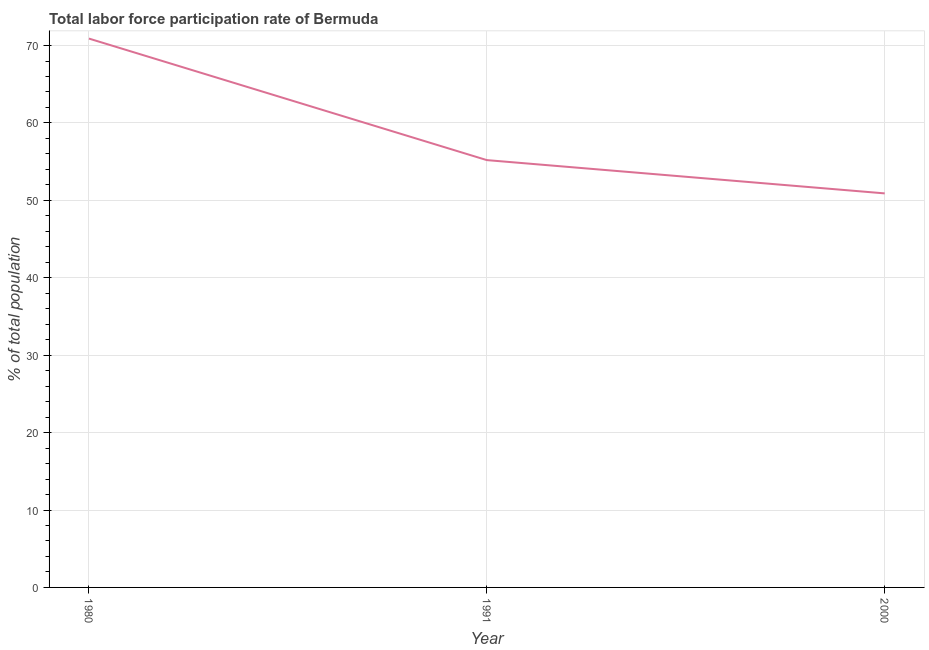What is the total labor force participation rate in 1991?
Offer a very short reply. 55.2. Across all years, what is the maximum total labor force participation rate?
Provide a succinct answer. 70.9. Across all years, what is the minimum total labor force participation rate?
Offer a terse response. 50.9. In which year was the total labor force participation rate maximum?
Your answer should be compact. 1980. In which year was the total labor force participation rate minimum?
Provide a short and direct response. 2000. What is the sum of the total labor force participation rate?
Ensure brevity in your answer.  177. What is the difference between the total labor force participation rate in 1980 and 2000?
Offer a very short reply. 20. What is the average total labor force participation rate per year?
Offer a terse response. 59. What is the median total labor force participation rate?
Give a very brief answer. 55.2. What is the ratio of the total labor force participation rate in 1991 to that in 2000?
Your answer should be very brief. 1.08. Is the difference between the total labor force participation rate in 1991 and 2000 greater than the difference between any two years?
Offer a very short reply. No. What is the difference between the highest and the second highest total labor force participation rate?
Give a very brief answer. 15.7. What is the difference between the highest and the lowest total labor force participation rate?
Give a very brief answer. 20. In how many years, is the total labor force participation rate greater than the average total labor force participation rate taken over all years?
Make the answer very short. 1. Does the total labor force participation rate monotonically increase over the years?
Offer a terse response. No. How many lines are there?
Your answer should be compact. 1. What is the difference between two consecutive major ticks on the Y-axis?
Provide a succinct answer. 10. Does the graph contain any zero values?
Give a very brief answer. No. Does the graph contain grids?
Keep it short and to the point. Yes. What is the title of the graph?
Your response must be concise. Total labor force participation rate of Bermuda. What is the label or title of the Y-axis?
Your answer should be very brief. % of total population. What is the % of total population in 1980?
Your response must be concise. 70.9. What is the % of total population of 1991?
Ensure brevity in your answer.  55.2. What is the % of total population of 2000?
Offer a terse response. 50.9. What is the difference between the % of total population in 1980 and 1991?
Keep it short and to the point. 15.7. What is the ratio of the % of total population in 1980 to that in 1991?
Your answer should be very brief. 1.28. What is the ratio of the % of total population in 1980 to that in 2000?
Keep it short and to the point. 1.39. What is the ratio of the % of total population in 1991 to that in 2000?
Give a very brief answer. 1.08. 